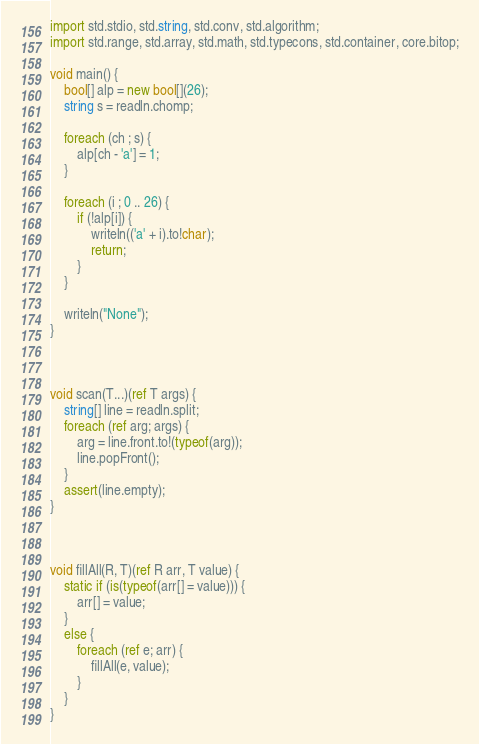<code> <loc_0><loc_0><loc_500><loc_500><_D_>import std.stdio, std.string, std.conv, std.algorithm;
import std.range, std.array, std.math, std.typecons, std.container, core.bitop;

void main() {
    bool[] alp = new bool[](26);
    string s = readln.chomp;

    foreach (ch ; s) {
        alp[ch - 'a'] = 1;
    }

    foreach (i ; 0 .. 26) {
        if (!alp[i]) {
            writeln(('a' + i).to!char);
            return;
        }
    }

    writeln("None");
}



void scan(T...)(ref T args) {
    string[] line = readln.split;
    foreach (ref arg; args) {
        arg = line.front.to!(typeof(arg));
        line.popFront();
    }
    assert(line.empty);
}



void fillAll(R, T)(ref R arr, T value) {
    static if (is(typeof(arr[] = value))) {
        arr[] = value;
    }
    else {
        foreach (ref e; arr) {
            fillAll(e, value);
        }
    }
}</code> 